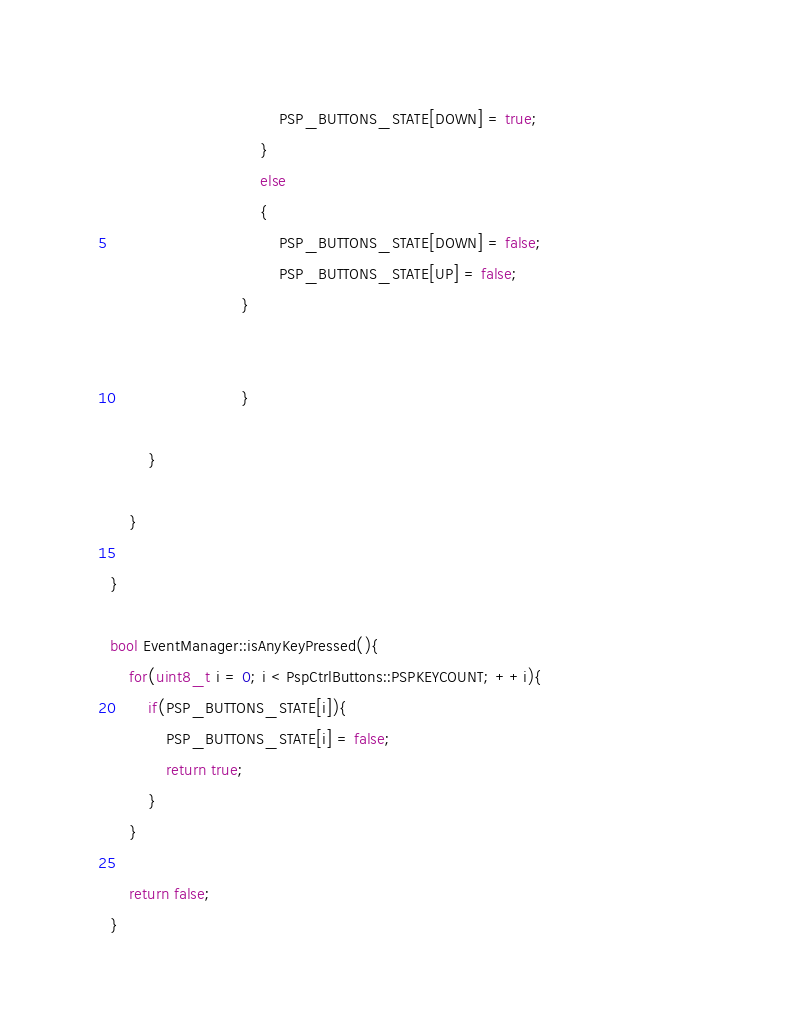<code> <loc_0><loc_0><loc_500><loc_500><_C++_>                                    PSP_BUTTONS_STATE[DOWN] = true;								
								}
								else
								{
                                    PSP_BUTTONS_STATE[DOWN] = false;
                                    PSP_BUTTONS_STATE[UP] = false;								
							}


                            }

        }

    }

}

bool EventManager::isAnyKeyPressed(){
    for(uint8_t i = 0; i < PspCtrlButtons::PSPKEYCOUNT; ++i){
        if(PSP_BUTTONS_STATE[i]){
            PSP_BUTTONS_STATE[i] = false;
            return true;
        }
    }

    return false;
}</code> 